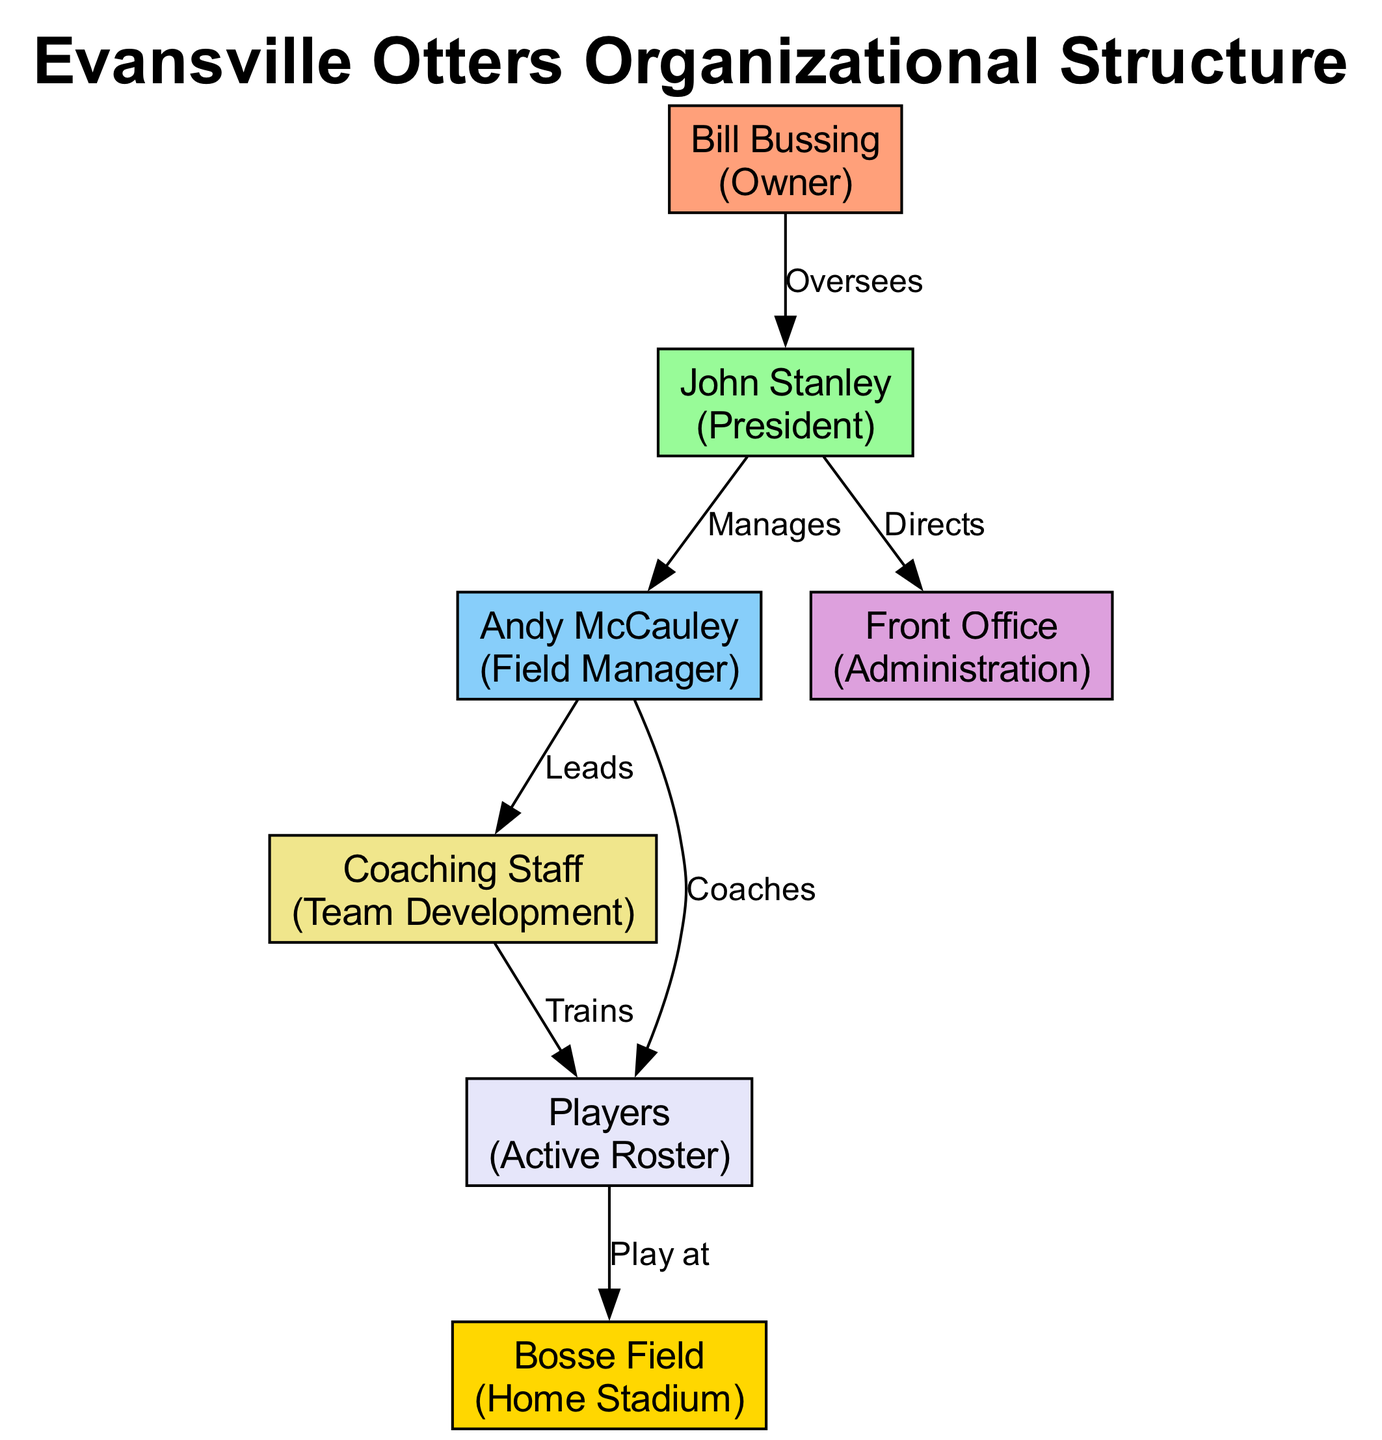What is the role of Bill Bussing? Bill Bussing is identified as the Owner in the diagram, which is mentioned in the node connected to his name.
Answer: Owner Who does the President manage? John Stanley, identified as the President, manages the Field Manager Andy McCauley, as indicated by the edge labeled "Manages" between the two nodes.
Answer: Field Manager How many players are on the active roster? The diagram illustrates one node labeled "Players" under the "Active Roster" role, indicating that there are players, but the specific number is not given in this context.
Answer: Players What entity oversees the President? The diagram shows that Bill Bussing, the Owner, oversees John Stanley, the President, as indicated by the edge labeled "Oversees".
Answer: President What is the relationship between the Field Manager and the Coaching Staff? The Field Manager Andy McCauley is responsible for leading the Coaching Staff, as indicated by the edge labeled "Leads".
Answer: Leads How does the Coaching Staff interact with the Players? The Coaching Staff trains the Players, demonstrated by the edge labeled "Trains" to the "Players" node.
Answer: Trains Where do the Players play their games? The Players play at Bosse Field, as represented in the last edge leading from the "Players" node to the "Home Stadium" node.
Answer: Bosse Field Who directs the Front Office? John Stanley, the President, directs the Front Office, indicated by the edge labeled "Directs" leading to the "Front Office" node.
Answer: Front Office What role does Andy McCauley have in relation to the Players? Andy McCauley, the Field Manager, coaches the Players, as shown by the edge labeled "Coaches".
Answer: Coaches 